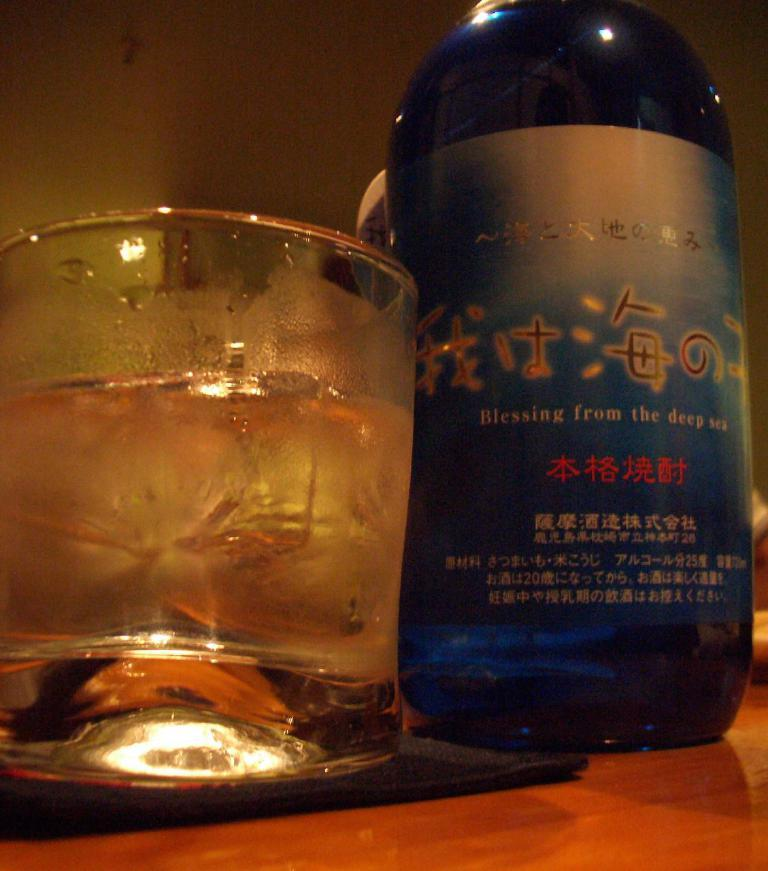<image>
Present a compact description of the photo's key features. Blue bottle saying "Blessing from the deep sea" next to a clear cup of liquid. 